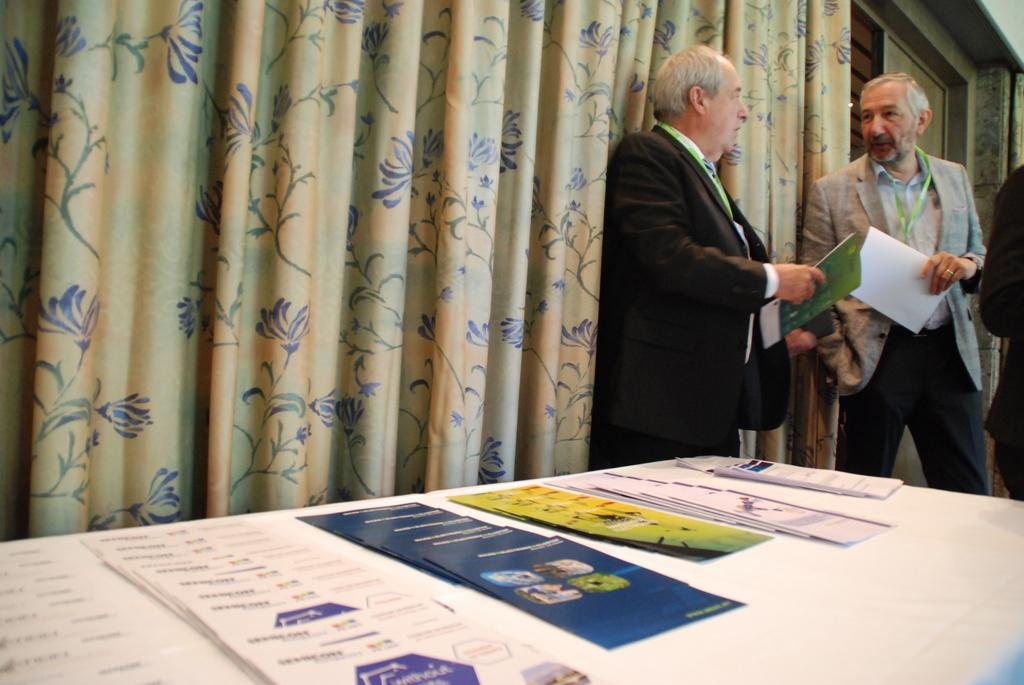How many people are in the image? There are people in the image, but the exact number is not specified. What are the people wearing in the image? The people are wearing coats in the image. Do the people have any identification in the image? Yes, the people have ID cards in the image. What are the people holding in the image? The people are holding books in the image. What can be seen in the background of the image? There is a curtain in the background of the image. What is present on the table at the bottom of the image? There are papers on a table at the bottom of the image. How many sheep are visible in the image? There are no sheep present in the image. What type of goose is sitting on the table in the image? There is no goose present in the image. 